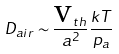Convert formula to latex. <formula><loc_0><loc_0><loc_500><loc_500>D _ { a i r } \sim \frac { \text {v} _ { t h } } { a ^ { 2 } } \frac { k T } { p _ { a } }</formula> 